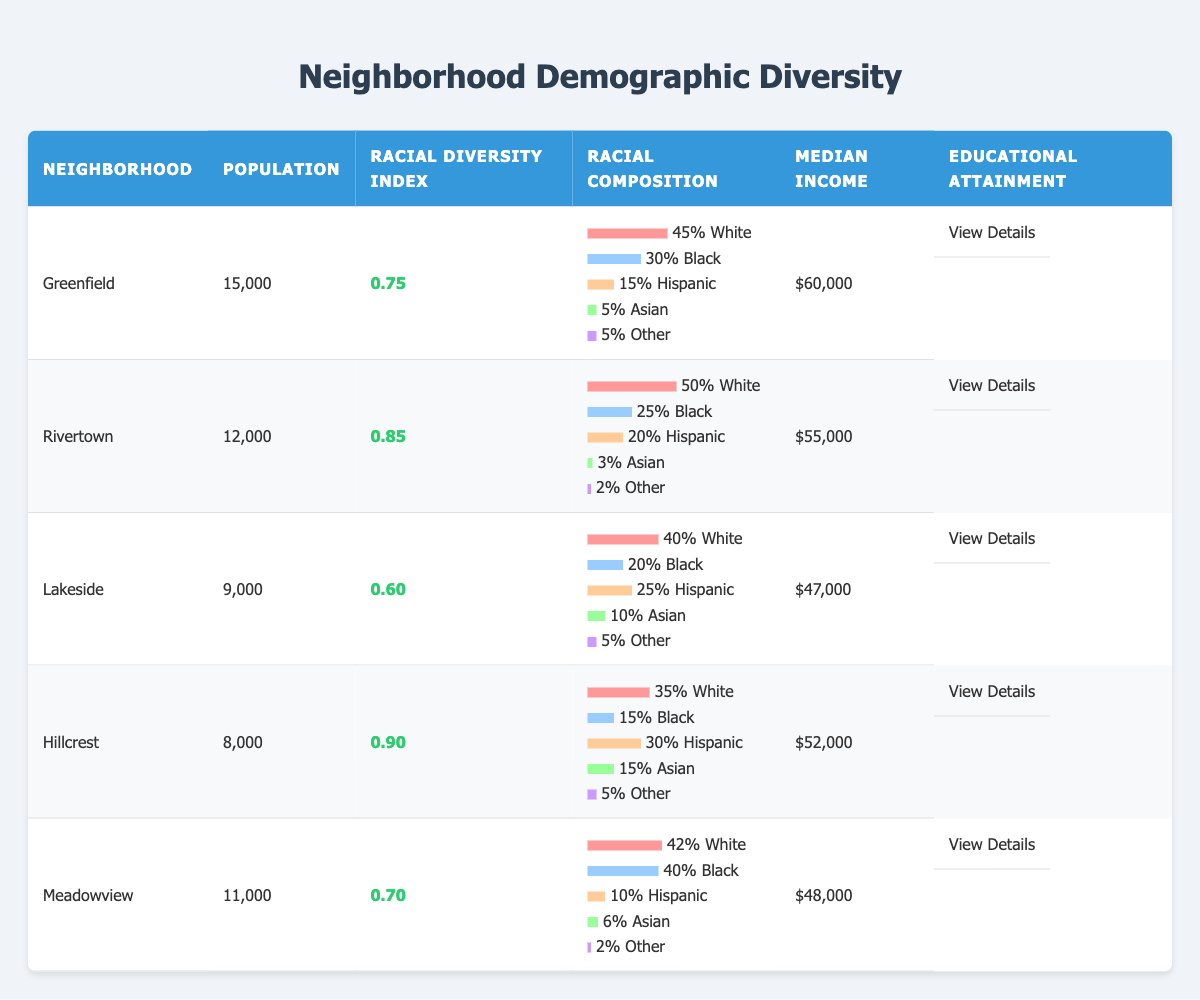What is the population of Greenfield? The table states that the population of Greenfield is listed in the 'Population' column, which shows the value of 15,000.
Answer: 15,000 What is the racial diversity index of Hillcrest? The racial diversity index for Hillcrest can be found in the 'Racial Diversity Index' column, showing a value of 0.90.
Answer: 0.90 Which neighborhood has the highest percentage of Hispanic residents? By examining the percentages in the 'Racial Composition' section for each neighborhood, Lakeside has 25% Hispanic, while Hillcrest has 30%. Comparing these shows that Hillcrest has the highest percentage.
Answer: Hillcrest What is the median income in Meadowview? The median income for Meadowview is directly listed in the 'Median Income' column, which indicates a value of $48,000.
Answer: $48,000 Is the percentage of Black residents higher in Rivertown than in Lakeside? In Rivertown, the percentage of Black residents is 25%, while in Lakeside, it is 20%. Since 25% is greater than 20%, this statement is true.
Answer: Yes What is the average racial diversity index of all neighborhoods? To find the average, I will sum the diversity indices (0.75 + 0.85 + 0.60 + 0.90 + 0.70) = 3.70. There are 5 neighborhoods, so the average is 3.70 / 5 = 0.74.
Answer: 0.74 Which neighborhood has the lowest median income, and what is that income? The 'Median Income' column indicates that Lakeside has the lowest value at $47,000. Confirming from the table shows this is indeed correct.
Answer: Lakeside; $47,000 How many neighborhoods have a racial diversity index higher than 0.80? The neighborhoods with a racial diversity index greater than 0.80 are Rivertown (0.85) and Hillcrest (0.90). This results in a total count of 2 neighborhoods.
Answer: 2 What is the racial diversity index of the neighborhood with the highest percentage of Asian residents? Hillcrest has 15% Asian residents, which is the highest among the neighborhoods. Its racial diversity index is 0.90.
Answer: 0.90 Is it true that all neighborhoods have at least 5% of residents identifying as Other? Reviewing the 'Racial Composition' for each neighborhood, all have at least 5% labeled as Other, making this statement true.
Answer: Yes 